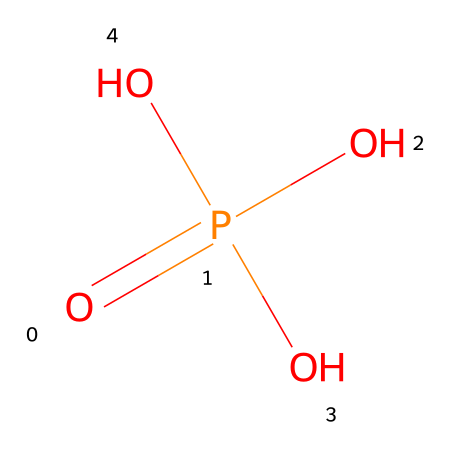What is the name of this chemical? The provided SMILES representation depicts a chemical with the structure that corresponds to phosphoric acid, which is commonly used in various applications, including LCD screen manufacturing.
Answer: phosphoric acid How many oxygen atoms are present in this chemical? By analyzing the SMILES representation, we can count the oxygen atoms indicated; there are four oxygen atoms in total (three in the hydroxyl groups and one double-bonded to phosphorus).
Answer: four What is the central atom in this chemical? The chemical structure shows that phosphorus is bonded to four oxygen atoms, indicating that phosphorus is the central atom in phosphoric acid.
Answer: phosphorus What type of acid is phosphoric acid? Given that phosphoric acid contains a phosphorus atom and is able to donate protons in an aqueous solution, it is classified as a mineral acid.
Answer: mineral How does phosphoric acid contribute to LCD screen manufacturing? In manufacturing, phosphoric acid is often utilized in the etching process to create patterns on glass substrates for LCD screens, thanks to its ability to form passivating layers.
Answer: etching agent What is the pH status of phosphoric acid in solution? Phosphoric acid is a weak acid, and in typical aqueous solutions, it usually results in a pH range that indicates acidity, generally below 7.
Answer: acidic What functional groups are present in phosphoric acid? The structure shows that phosphoric acid contains hydroxyl functional groups (-OH) as well as a phosphate group, which is characteristic of its acidic behavior.
Answer: hydroxyl and phosphate 